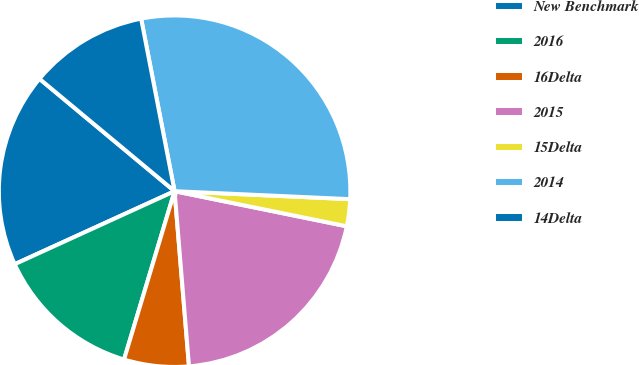Convert chart. <chart><loc_0><loc_0><loc_500><loc_500><pie_chart><fcel>New Benchmark<fcel>2016<fcel>16Delta<fcel>2015<fcel>15Delta<fcel>2014<fcel>14Delta<nl><fcel>17.86%<fcel>13.54%<fcel>5.95%<fcel>20.49%<fcel>2.48%<fcel>28.77%<fcel>10.91%<nl></chart> 